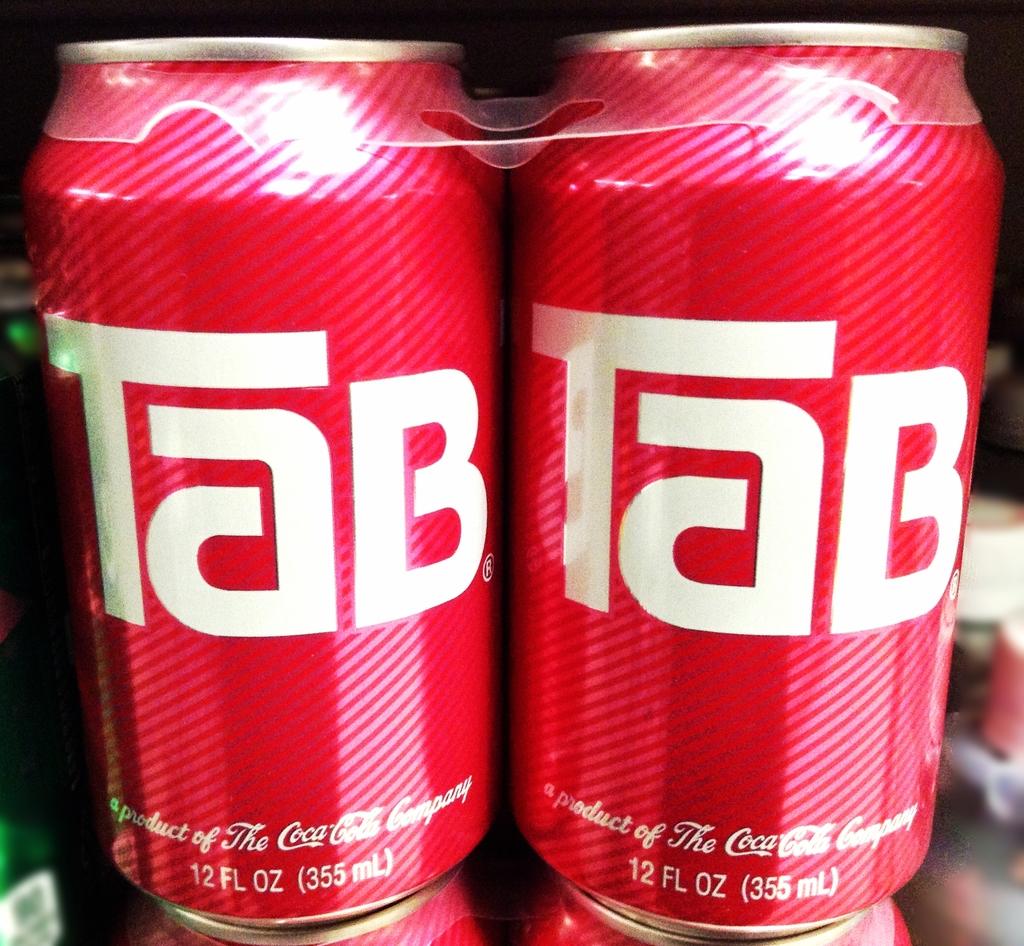What is the name of this drink?
Offer a very short reply. Tab. How many ounces is this?
Make the answer very short. 12. 